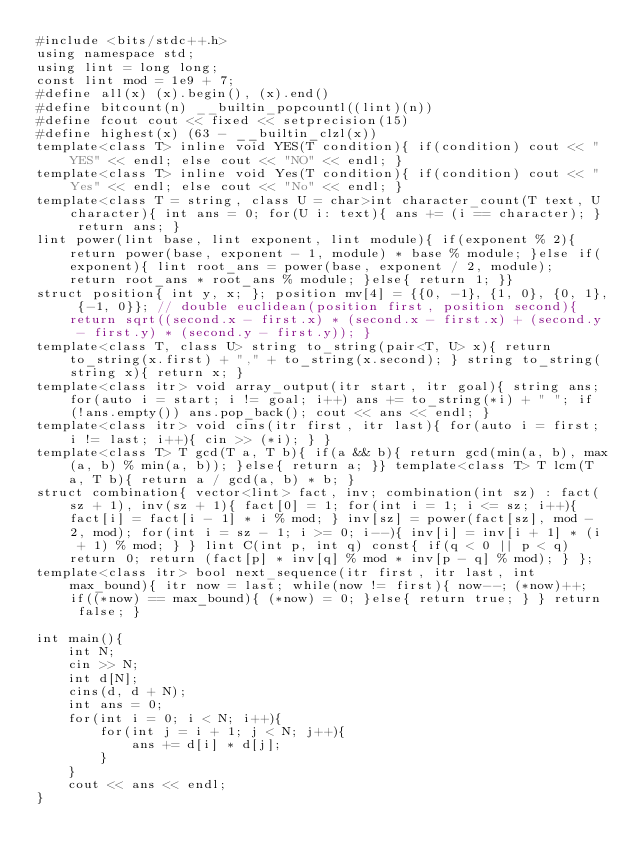Convert code to text. <code><loc_0><loc_0><loc_500><loc_500><_C++_>#include <bits/stdc++.h>
using namespace std;
using lint = long long;
const lint mod = 1e9 + 7;
#define all(x) (x).begin(), (x).end()
#define bitcount(n) __builtin_popcountl((lint)(n))
#define fcout cout << fixed << setprecision(15)
#define highest(x) (63 - __builtin_clzl(x))
template<class T> inline void YES(T condition){ if(condition) cout << "YES" << endl; else cout << "NO" << endl; }
template<class T> inline void Yes(T condition){ if(condition) cout << "Yes" << endl; else cout << "No" << endl; }
template<class T = string, class U = char>int character_count(T text, U character){ int ans = 0; for(U i: text){ ans += (i == character); } return ans; }
lint power(lint base, lint exponent, lint module){ if(exponent % 2){ return power(base, exponent - 1, module) * base % module; }else if(exponent){ lint root_ans = power(base, exponent / 2, module); return root_ans * root_ans % module; }else{ return 1; }}
struct position{ int y, x; }; position mv[4] = {{0, -1}, {1, 0}, {0, 1}, {-1, 0}}; // double euclidean(position first, position second){ return sqrt((second.x - first.x) * (second.x - first.x) + (second.y - first.y) * (second.y - first.y)); }
template<class T, class U> string to_string(pair<T, U> x){ return to_string(x.first) + "," + to_string(x.second); } string to_string(string x){ return x; }
template<class itr> void array_output(itr start, itr goal){ string ans; for(auto i = start; i != goal; i++) ans += to_string(*i) + " "; if(!ans.empty()) ans.pop_back(); cout << ans << endl; }
template<class itr> void cins(itr first, itr last){ for(auto i = first; i != last; i++){ cin >> (*i); } }
template<class T> T gcd(T a, T b){ if(a && b){ return gcd(min(a, b), max(a, b) % min(a, b)); }else{ return a; }} template<class T> T lcm(T a, T b){ return a / gcd(a, b) * b; }
struct combination{ vector<lint> fact, inv; combination(int sz) : fact(sz + 1), inv(sz + 1){ fact[0] = 1; for(int i = 1; i <= sz; i++){ fact[i] = fact[i - 1] * i % mod; } inv[sz] = power(fact[sz], mod - 2, mod); for(int i = sz - 1; i >= 0; i--){ inv[i] = inv[i + 1] * (i + 1) % mod; } } lint C(int p, int q) const{ if(q < 0 || p < q) return 0; return (fact[p] * inv[q] % mod * inv[p - q] % mod); } };
template<class itr> bool next_sequence(itr first, itr last, int max_bound){ itr now = last; while(now != first){ now--; (*now)++; if((*now) == max_bound){ (*now) = 0; }else{ return true; } } return false; }

int main(){
    int N;
    cin >> N;
    int d[N];
    cins(d, d + N);
    int ans = 0;
    for(int i = 0; i < N; i++){
        for(int j = i + 1; j < N; j++){
            ans += d[i] * d[j];
        }
    }
    cout << ans << endl;
}</code> 